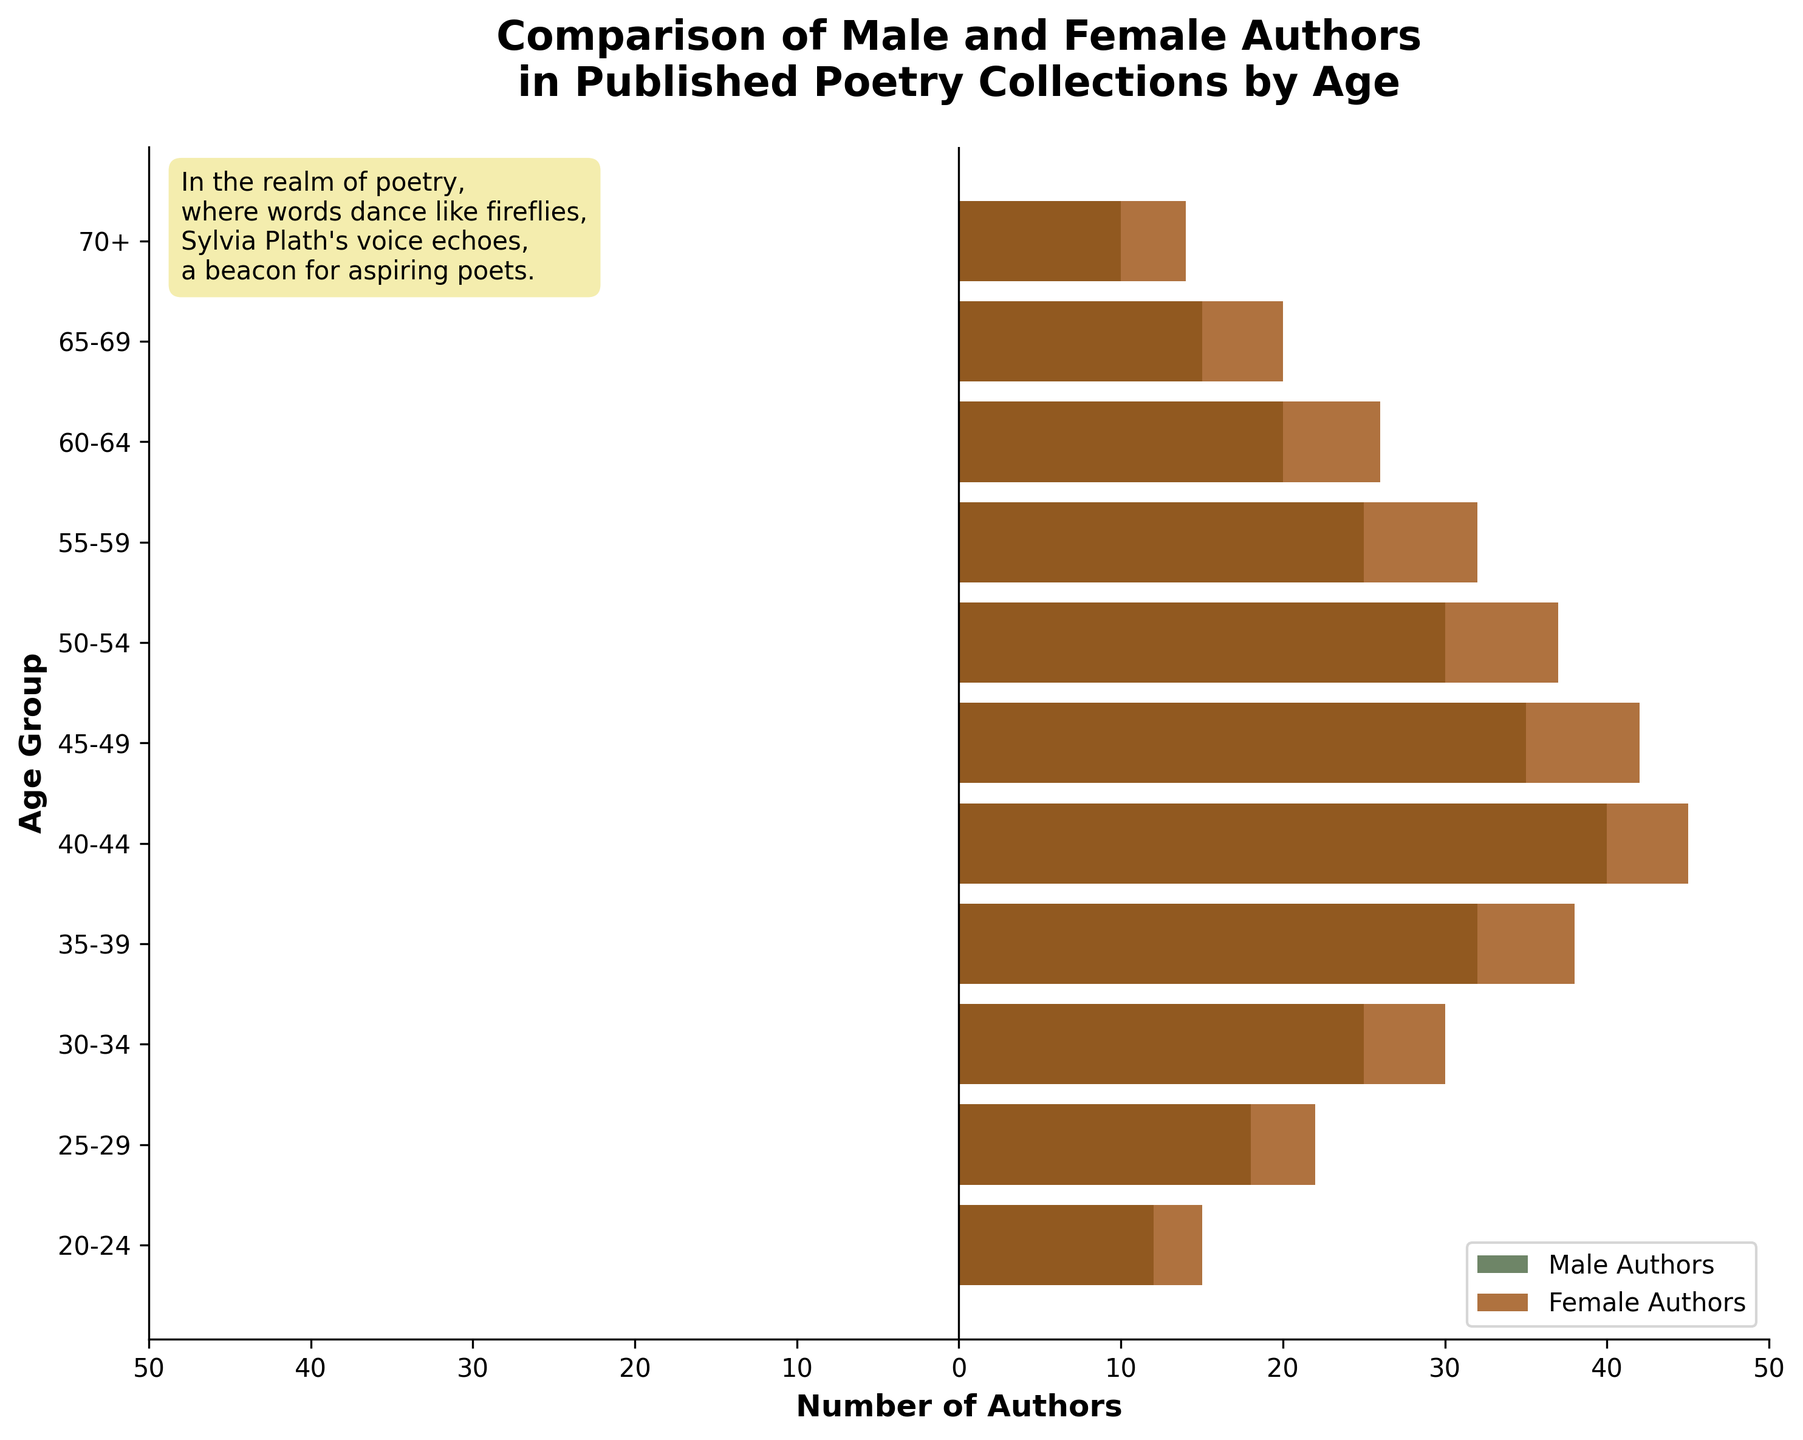What is the age group with the highest number of male authors? The age group with the highest number of male authors can be identified by looking for the longest bar extending to the right on the male authors' side. The "40-44" age group has a bar extending to 40, which is the highest among all male authors' age groups.
Answer: 40-44 What is the total number of female authors in the "30-34" and "35-39" age groups combined? To find the total number of female authors in the "30-34" age group and the "35-39" age group, add the negative values in the data for both age groups and convert them to positive. Female authors in "30-34" is -30, and in "35-39" is -38. So, the total is 30 + 38 = 68.
Answer: 68 Which gender has more authors published in the "50-54" age group? To determine which gender has more authors in the "50-54" age group, compare the lengths of the bars extending to the left and right. The bar for male authors extends to 30, while the bar for female authors extends to 37. The female authors' bar is longer, indicating more female authors.
Answer: Female How many more male authors are there in the "40-44" age group compared to the "65-69" age group? The number of male authors in the "40-44" age group is 40, and in the "65-69" age group is 15. The difference is 40 - 15 = 25.
Answer: 25 What is the total number of male authors aged between 50 and 64? To find the total number of male authors aged between 50 and 64, sum the values from the "50-54," "55-59," and "60-64" age groups. The sum is 30 + 25 + 20 = 75.
Answer: 75 In which age group do female authors first surpass 30 in number? To find the first age group where the number of female authors surpasses 30, look for the first bar on the female side reaching beyond the 30 mark. The "30-34" age group has 30 female authors, but the "35-39" age group has 38 female authors, which is the first instance surpassing 30.
Answer: 35-39 What's the difference between the number of male and female authors in the "45-49" age group? The number of male authors in the "45-49" age group is 35, and the number of female authors is 42. The difference is 42 - 35 = 7.
Answer: 7 